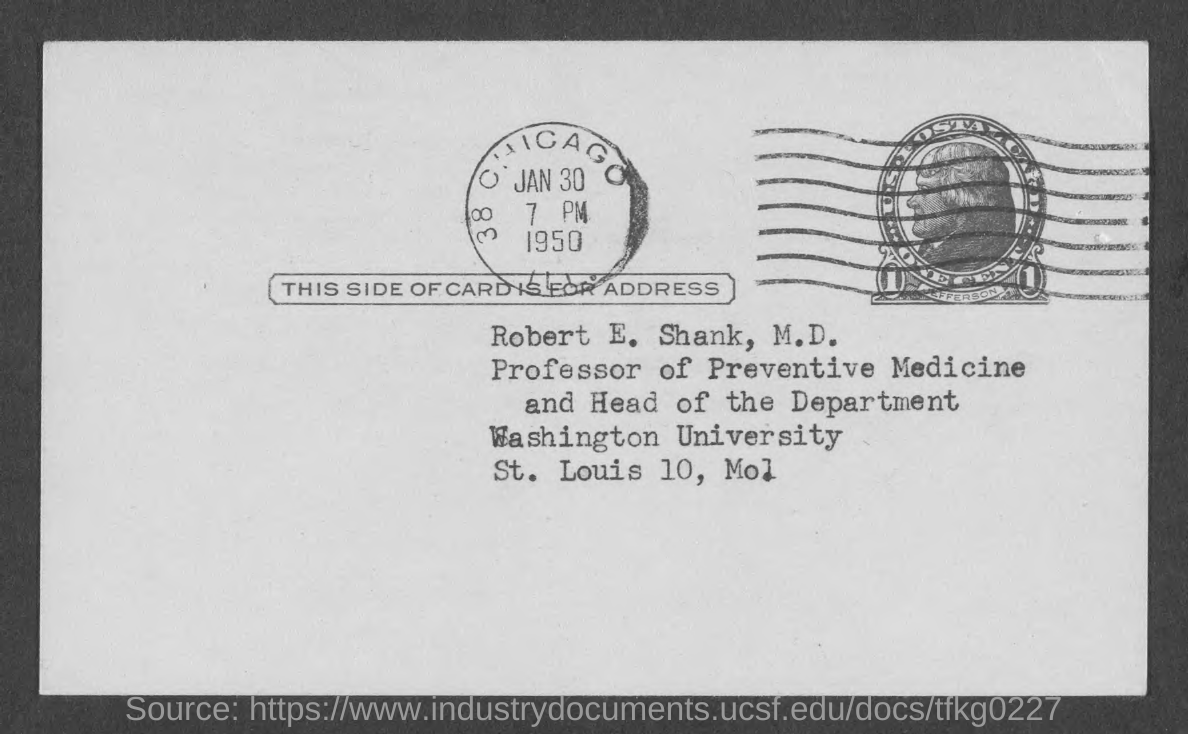What is the time?
Give a very brief answer. 7 PM. 